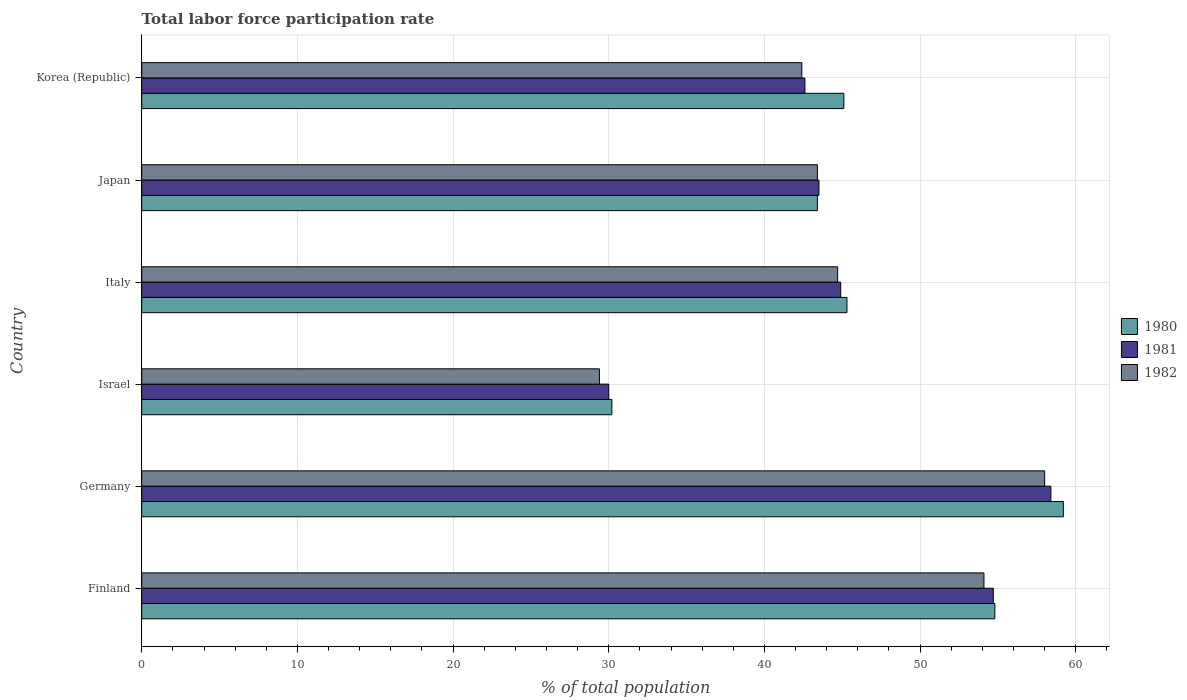How many different coloured bars are there?
Your response must be concise. 3. How many groups of bars are there?
Your answer should be very brief. 6. Are the number of bars on each tick of the Y-axis equal?
Offer a terse response. Yes. How many bars are there on the 3rd tick from the top?
Offer a very short reply. 3. What is the label of the 5th group of bars from the top?
Your answer should be compact. Germany. What is the total labor force participation rate in 1981 in Israel?
Your answer should be very brief. 30. Across all countries, what is the maximum total labor force participation rate in 1981?
Offer a terse response. 58.4. Across all countries, what is the minimum total labor force participation rate in 1982?
Your answer should be very brief. 29.4. In which country was the total labor force participation rate in 1980 maximum?
Ensure brevity in your answer.  Germany. What is the total total labor force participation rate in 1982 in the graph?
Offer a very short reply. 272. What is the difference between the total labor force participation rate in 1981 in Japan and that in Korea (Republic)?
Your answer should be compact. 0.9. What is the average total labor force participation rate in 1980 per country?
Offer a very short reply. 46.33. What is the difference between the total labor force participation rate in 1982 and total labor force participation rate in 1981 in Germany?
Give a very brief answer. -0.4. What is the ratio of the total labor force participation rate in 1981 in Germany to that in Italy?
Ensure brevity in your answer.  1.3. Is the total labor force participation rate in 1980 in Finland less than that in Korea (Republic)?
Your answer should be very brief. No. What is the difference between the highest and the second highest total labor force participation rate in 1980?
Make the answer very short. 4.4. What is the difference between the highest and the lowest total labor force participation rate in 1982?
Offer a very short reply. 28.6. What does the 2nd bar from the top in Germany represents?
Provide a succinct answer. 1981. What does the 2nd bar from the bottom in Japan represents?
Offer a very short reply. 1981. Is it the case that in every country, the sum of the total labor force participation rate in 1982 and total labor force participation rate in 1980 is greater than the total labor force participation rate in 1981?
Your answer should be compact. Yes. How many bars are there?
Your response must be concise. 18. Are all the bars in the graph horizontal?
Your answer should be very brief. Yes. How many countries are there in the graph?
Offer a terse response. 6. Are the values on the major ticks of X-axis written in scientific E-notation?
Give a very brief answer. No. Does the graph contain any zero values?
Your answer should be compact. No. Where does the legend appear in the graph?
Offer a very short reply. Center right. How many legend labels are there?
Your response must be concise. 3. How are the legend labels stacked?
Keep it short and to the point. Vertical. What is the title of the graph?
Provide a short and direct response. Total labor force participation rate. What is the label or title of the X-axis?
Ensure brevity in your answer.  % of total population. What is the % of total population in 1980 in Finland?
Ensure brevity in your answer.  54.8. What is the % of total population in 1981 in Finland?
Provide a short and direct response. 54.7. What is the % of total population of 1982 in Finland?
Your answer should be compact. 54.1. What is the % of total population in 1980 in Germany?
Provide a short and direct response. 59.2. What is the % of total population of 1981 in Germany?
Your answer should be very brief. 58.4. What is the % of total population of 1980 in Israel?
Ensure brevity in your answer.  30.2. What is the % of total population of 1981 in Israel?
Your response must be concise. 30. What is the % of total population in 1982 in Israel?
Ensure brevity in your answer.  29.4. What is the % of total population in 1980 in Italy?
Give a very brief answer. 45.3. What is the % of total population of 1981 in Italy?
Your response must be concise. 44.9. What is the % of total population in 1982 in Italy?
Offer a very short reply. 44.7. What is the % of total population in 1980 in Japan?
Provide a short and direct response. 43.4. What is the % of total population of 1981 in Japan?
Your response must be concise. 43.5. What is the % of total population in 1982 in Japan?
Offer a terse response. 43.4. What is the % of total population of 1980 in Korea (Republic)?
Provide a short and direct response. 45.1. What is the % of total population in 1981 in Korea (Republic)?
Make the answer very short. 42.6. What is the % of total population of 1982 in Korea (Republic)?
Provide a succinct answer. 42.4. Across all countries, what is the maximum % of total population in 1980?
Provide a short and direct response. 59.2. Across all countries, what is the maximum % of total population in 1981?
Provide a succinct answer. 58.4. Across all countries, what is the maximum % of total population in 1982?
Offer a terse response. 58. Across all countries, what is the minimum % of total population in 1980?
Offer a terse response. 30.2. Across all countries, what is the minimum % of total population of 1982?
Your response must be concise. 29.4. What is the total % of total population in 1980 in the graph?
Give a very brief answer. 278. What is the total % of total population of 1981 in the graph?
Offer a very short reply. 274.1. What is the total % of total population in 1982 in the graph?
Provide a succinct answer. 272. What is the difference between the % of total population of 1980 in Finland and that in Germany?
Provide a short and direct response. -4.4. What is the difference between the % of total population of 1980 in Finland and that in Israel?
Offer a terse response. 24.6. What is the difference between the % of total population in 1981 in Finland and that in Israel?
Your answer should be very brief. 24.7. What is the difference between the % of total population in 1982 in Finland and that in Israel?
Give a very brief answer. 24.7. What is the difference between the % of total population in 1980 in Finland and that in Italy?
Offer a very short reply. 9.5. What is the difference between the % of total population of 1980 in Finland and that in Japan?
Ensure brevity in your answer.  11.4. What is the difference between the % of total population in 1981 in Finland and that in Japan?
Provide a succinct answer. 11.2. What is the difference between the % of total population in 1980 in Finland and that in Korea (Republic)?
Offer a terse response. 9.7. What is the difference between the % of total population of 1981 in Finland and that in Korea (Republic)?
Give a very brief answer. 12.1. What is the difference between the % of total population of 1982 in Finland and that in Korea (Republic)?
Your response must be concise. 11.7. What is the difference between the % of total population in 1981 in Germany and that in Israel?
Offer a very short reply. 28.4. What is the difference between the % of total population in 1982 in Germany and that in Israel?
Ensure brevity in your answer.  28.6. What is the difference between the % of total population in 1981 in Germany and that in Italy?
Keep it short and to the point. 13.5. What is the difference between the % of total population in 1980 in Germany and that in Japan?
Offer a very short reply. 15.8. What is the difference between the % of total population in 1981 in Germany and that in Japan?
Keep it short and to the point. 14.9. What is the difference between the % of total population in 1980 in Germany and that in Korea (Republic)?
Your answer should be very brief. 14.1. What is the difference between the % of total population in 1980 in Israel and that in Italy?
Provide a succinct answer. -15.1. What is the difference between the % of total population of 1981 in Israel and that in Italy?
Offer a terse response. -14.9. What is the difference between the % of total population in 1982 in Israel and that in Italy?
Your response must be concise. -15.3. What is the difference between the % of total population of 1980 in Israel and that in Japan?
Ensure brevity in your answer.  -13.2. What is the difference between the % of total population of 1981 in Israel and that in Japan?
Offer a terse response. -13.5. What is the difference between the % of total population in 1982 in Israel and that in Japan?
Provide a succinct answer. -14. What is the difference between the % of total population in 1980 in Israel and that in Korea (Republic)?
Give a very brief answer. -14.9. What is the difference between the % of total population in 1982 in Israel and that in Korea (Republic)?
Make the answer very short. -13. What is the difference between the % of total population of 1980 in Italy and that in Japan?
Make the answer very short. 1.9. What is the difference between the % of total population of 1981 in Italy and that in Japan?
Make the answer very short. 1.4. What is the difference between the % of total population in 1980 in Japan and that in Korea (Republic)?
Your answer should be very brief. -1.7. What is the difference between the % of total population in 1982 in Japan and that in Korea (Republic)?
Your answer should be compact. 1. What is the difference between the % of total population of 1981 in Finland and the % of total population of 1982 in Germany?
Make the answer very short. -3.3. What is the difference between the % of total population in 1980 in Finland and the % of total population in 1981 in Israel?
Offer a terse response. 24.8. What is the difference between the % of total population of 1980 in Finland and the % of total population of 1982 in Israel?
Provide a short and direct response. 25.4. What is the difference between the % of total population in 1981 in Finland and the % of total population in 1982 in Israel?
Your answer should be very brief. 25.3. What is the difference between the % of total population of 1980 in Finland and the % of total population of 1981 in Korea (Republic)?
Your response must be concise. 12.2. What is the difference between the % of total population of 1980 in Finland and the % of total population of 1982 in Korea (Republic)?
Provide a succinct answer. 12.4. What is the difference between the % of total population of 1981 in Finland and the % of total population of 1982 in Korea (Republic)?
Your response must be concise. 12.3. What is the difference between the % of total population in 1980 in Germany and the % of total population in 1981 in Israel?
Provide a succinct answer. 29.2. What is the difference between the % of total population in 1980 in Germany and the % of total population in 1982 in Israel?
Your answer should be compact. 29.8. What is the difference between the % of total population of 1981 in Germany and the % of total population of 1982 in Israel?
Keep it short and to the point. 29. What is the difference between the % of total population of 1980 in Germany and the % of total population of 1981 in Italy?
Offer a very short reply. 14.3. What is the difference between the % of total population in 1980 in Germany and the % of total population in 1982 in Italy?
Give a very brief answer. 14.5. What is the difference between the % of total population in 1980 in Germany and the % of total population in 1982 in Japan?
Provide a short and direct response. 15.8. What is the difference between the % of total population of 1980 in Germany and the % of total population of 1982 in Korea (Republic)?
Your answer should be very brief. 16.8. What is the difference between the % of total population of 1981 in Germany and the % of total population of 1982 in Korea (Republic)?
Make the answer very short. 16. What is the difference between the % of total population of 1980 in Israel and the % of total population of 1981 in Italy?
Provide a succinct answer. -14.7. What is the difference between the % of total population of 1980 in Israel and the % of total population of 1982 in Italy?
Make the answer very short. -14.5. What is the difference between the % of total population of 1981 in Israel and the % of total population of 1982 in Italy?
Provide a succinct answer. -14.7. What is the difference between the % of total population in 1980 in Israel and the % of total population in 1981 in Japan?
Keep it short and to the point. -13.3. What is the difference between the % of total population in 1980 in Israel and the % of total population in 1981 in Korea (Republic)?
Keep it short and to the point. -12.4. What is the difference between the % of total population in 1980 in Israel and the % of total population in 1982 in Korea (Republic)?
Keep it short and to the point. -12.2. What is the difference between the % of total population of 1980 in Italy and the % of total population of 1981 in Japan?
Offer a very short reply. 1.8. What is the difference between the % of total population in 1981 in Italy and the % of total population in 1982 in Japan?
Offer a terse response. 1.5. What is the difference between the % of total population in 1980 in Italy and the % of total population in 1982 in Korea (Republic)?
Offer a very short reply. 2.9. What is the difference between the % of total population in 1981 in Italy and the % of total population in 1982 in Korea (Republic)?
Your response must be concise. 2.5. What is the difference between the % of total population of 1980 in Japan and the % of total population of 1981 in Korea (Republic)?
Offer a very short reply. 0.8. What is the difference between the % of total population of 1980 in Japan and the % of total population of 1982 in Korea (Republic)?
Make the answer very short. 1. What is the difference between the % of total population of 1981 in Japan and the % of total population of 1982 in Korea (Republic)?
Ensure brevity in your answer.  1.1. What is the average % of total population in 1980 per country?
Make the answer very short. 46.33. What is the average % of total population of 1981 per country?
Make the answer very short. 45.68. What is the average % of total population of 1982 per country?
Offer a terse response. 45.33. What is the difference between the % of total population of 1980 and % of total population of 1981 in Finland?
Provide a short and direct response. 0.1. What is the difference between the % of total population in 1980 and % of total population in 1982 in Finland?
Make the answer very short. 0.7. What is the difference between the % of total population in 1980 and % of total population in 1982 in Germany?
Your answer should be very brief. 1.2. What is the difference between the % of total population of 1981 and % of total population of 1982 in Germany?
Ensure brevity in your answer.  0.4. What is the difference between the % of total population of 1980 and % of total population of 1981 in Israel?
Provide a short and direct response. 0.2. What is the difference between the % of total population of 1980 and % of total population of 1981 in Italy?
Offer a terse response. 0.4. What is the difference between the % of total population of 1980 and % of total population of 1982 in Italy?
Provide a succinct answer. 0.6. What is the difference between the % of total population of 1981 and % of total population of 1982 in Italy?
Keep it short and to the point. 0.2. What is the difference between the % of total population of 1980 and % of total population of 1981 in Japan?
Offer a very short reply. -0.1. What is the difference between the % of total population of 1981 and % of total population of 1982 in Japan?
Provide a short and direct response. 0.1. What is the difference between the % of total population in 1980 and % of total population in 1981 in Korea (Republic)?
Offer a terse response. 2.5. What is the ratio of the % of total population of 1980 in Finland to that in Germany?
Offer a very short reply. 0.93. What is the ratio of the % of total population in 1981 in Finland to that in Germany?
Offer a terse response. 0.94. What is the ratio of the % of total population of 1982 in Finland to that in Germany?
Your response must be concise. 0.93. What is the ratio of the % of total population in 1980 in Finland to that in Israel?
Provide a succinct answer. 1.81. What is the ratio of the % of total population in 1981 in Finland to that in Israel?
Ensure brevity in your answer.  1.82. What is the ratio of the % of total population of 1982 in Finland to that in Israel?
Ensure brevity in your answer.  1.84. What is the ratio of the % of total population of 1980 in Finland to that in Italy?
Your answer should be compact. 1.21. What is the ratio of the % of total population of 1981 in Finland to that in Italy?
Give a very brief answer. 1.22. What is the ratio of the % of total population in 1982 in Finland to that in Italy?
Ensure brevity in your answer.  1.21. What is the ratio of the % of total population of 1980 in Finland to that in Japan?
Offer a very short reply. 1.26. What is the ratio of the % of total population of 1981 in Finland to that in Japan?
Offer a very short reply. 1.26. What is the ratio of the % of total population in 1982 in Finland to that in Japan?
Give a very brief answer. 1.25. What is the ratio of the % of total population in 1980 in Finland to that in Korea (Republic)?
Make the answer very short. 1.22. What is the ratio of the % of total population in 1981 in Finland to that in Korea (Republic)?
Ensure brevity in your answer.  1.28. What is the ratio of the % of total population of 1982 in Finland to that in Korea (Republic)?
Ensure brevity in your answer.  1.28. What is the ratio of the % of total population of 1980 in Germany to that in Israel?
Offer a very short reply. 1.96. What is the ratio of the % of total population in 1981 in Germany to that in Israel?
Keep it short and to the point. 1.95. What is the ratio of the % of total population in 1982 in Germany to that in Israel?
Ensure brevity in your answer.  1.97. What is the ratio of the % of total population in 1980 in Germany to that in Italy?
Make the answer very short. 1.31. What is the ratio of the % of total population in 1981 in Germany to that in Italy?
Provide a succinct answer. 1.3. What is the ratio of the % of total population of 1982 in Germany to that in Italy?
Your answer should be compact. 1.3. What is the ratio of the % of total population in 1980 in Germany to that in Japan?
Give a very brief answer. 1.36. What is the ratio of the % of total population in 1981 in Germany to that in Japan?
Give a very brief answer. 1.34. What is the ratio of the % of total population of 1982 in Germany to that in Japan?
Ensure brevity in your answer.  1.34. What is the ratio of the % of total population in 1980 in Germany to that in Korea (Republic)?
Make the answer very short. 1.31. What is the ratio of the % of total population of 1981 in Germany to that in Korea (Republic)?
Keep it short and to the point. 1.37. What is the ratio of the % of total population of 1982 in Germany to that in Korea (Republic)?
Your response must be concise. 1.37. What is the ratio of the % of total population in 1981 in Israel to that in Italy?
Keep it short and to the point. 0.67. What is the ratio of the % of total population of 1982 in Israel to that in Italy?
Ensure brevity in your answer.  0.66. What is the ratio of the % of total population of 1980 in Israel to that in Japan?
Your answer should be compact. 0.7. What is the ratio of the % of total population of 1981 in Israel to that in Japan?
Make the answer very short. 0.69. What is the ratio of the % of total population of 1982 in Israel to that in Japan?
Offer a terse response. 0.68. What is the ratio of the % of total population in 1980 in Israel to that in Korea (Republic)?
Provide a succinct answer. 0.67. What is the ratio of the % of total population in 1981 in Israel to that in Korea (Republic)?
Ensure brevity in your answer.  0.7. What is the ratio of the % of total population of 1982 in Israel to that in Korea (Republic)?
Make the answer very short. 0.69. What is the ratio of the % of total population of 1980 in Italy to that in Japan?
Provide a succinct answer. 1.04. What is the ratio of the % of total population of 1981 in Italy to that in Japan?
Keep it short and to the point. 1.03. What is the ratio of the % of total population of 1980 in Italy to that in Korea (Republic)?
Keep it short and to the point. 1. What is the ratio of the % of total population of 1981 in Italy to that in Korea (Republic)?
Provide a short and direct response. 1.05. What is the ratio of the % of total population of 1982 in Italy to that in Korea (Republic)?
Ensure brevity in your answer.  1.05. What is the ratio of the % of total population in 1980 in Japan to that in Korea (Republic)?
Ensure brevity in your answer.  0.96. What is the ratio of the % of total population in 1981 in Japan to that in Korea (Republic)?
Give a very brief answer. 1.02. What is the ratio of the % of total population of 1982 in Japan to that in Korea (Republic)?
Ensure brevity in your answer.  1.02. What is the difference between the highest and the lowest % of total population of 1981?
Offer a terse response. 28.4. What is the difference between the highest and the lowest % of total population in 1982?
Give a very brief answer. 28.6. 